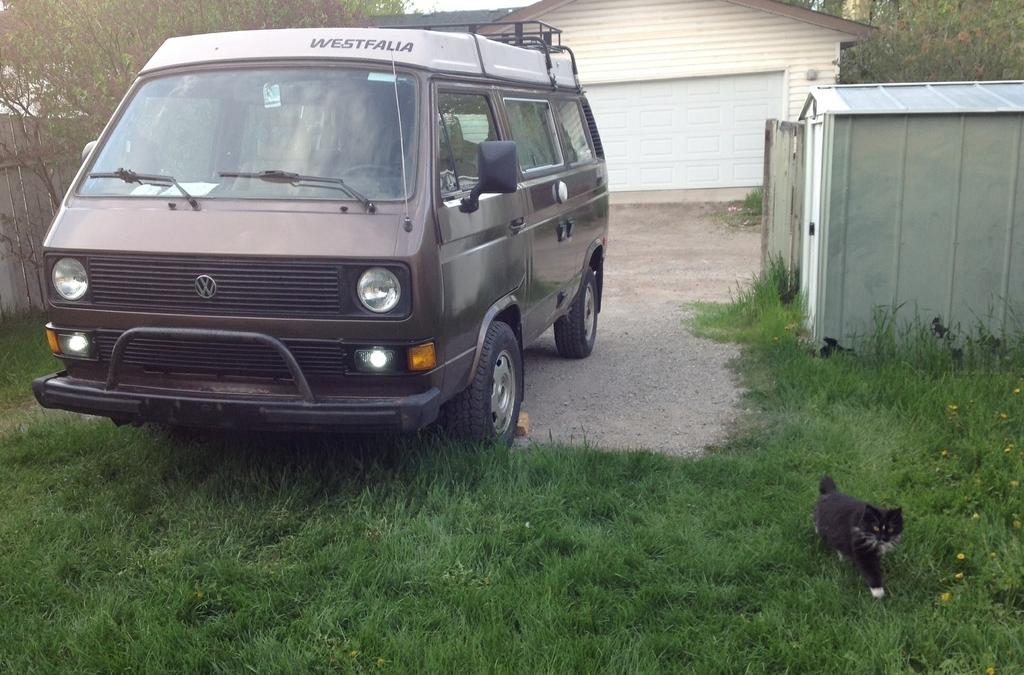What is the main subject in the image? There is a vehicle in the image. What else can be seen in the image besides the vehicle? There is a cat on the grass, flowers, a fence, seeds, and trees in the image. Can you describe the cat's location in the image? The cat is on the grass in the image. What type of vegetation is present in the image? There are flowers and trees in the image. What is the background of the image? The background of the image includes a fence, seeds, and trees. What type of paper can be seen in the image? There is no paper present in the image. How many bushes are visible in the image? There are no bushes mentioned in the provided facts, so we cannot determine the number of bushes in the image. 